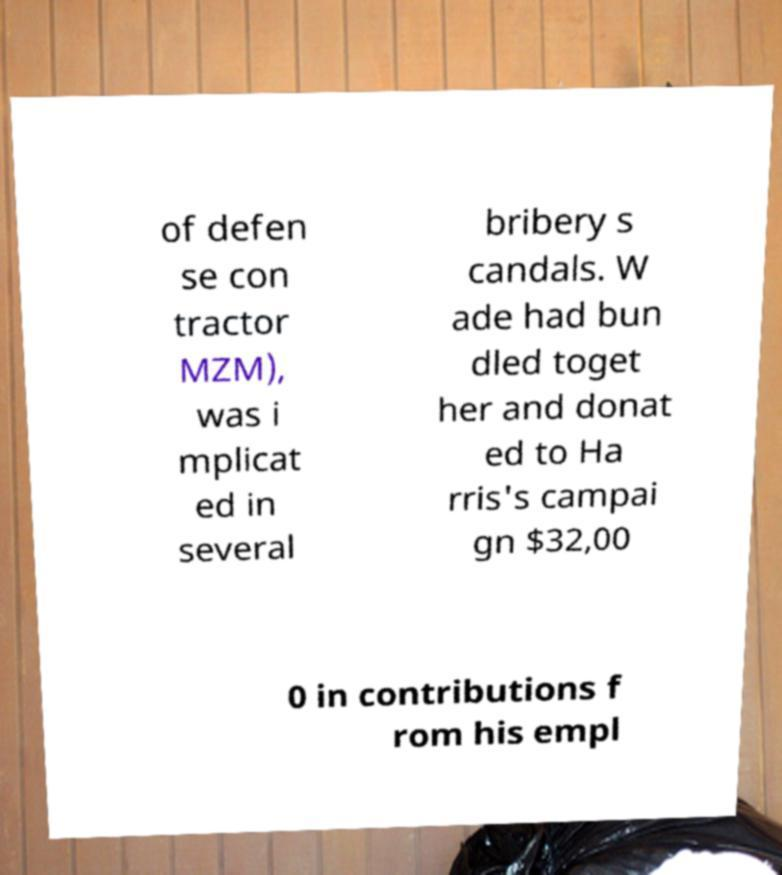What messages or text are displayed in this image? I need them in a readable, typed format. of defen se con tractor MZM), was i mplicat ed in several bribery s candals. W ade had bun dled toget her and donat ed to Ha rris's campai gn $32,00 0 in contributions f rom his empl 